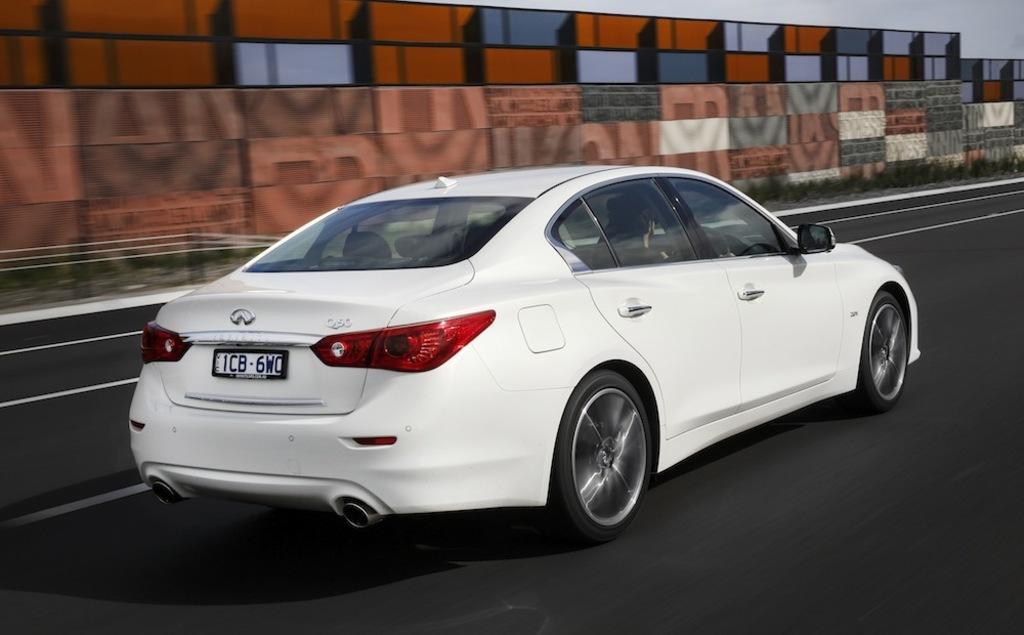Describe this image in one or two sentences. In this image I can see a white color car visible on the road ,at the top I can see the wall and the sky. 